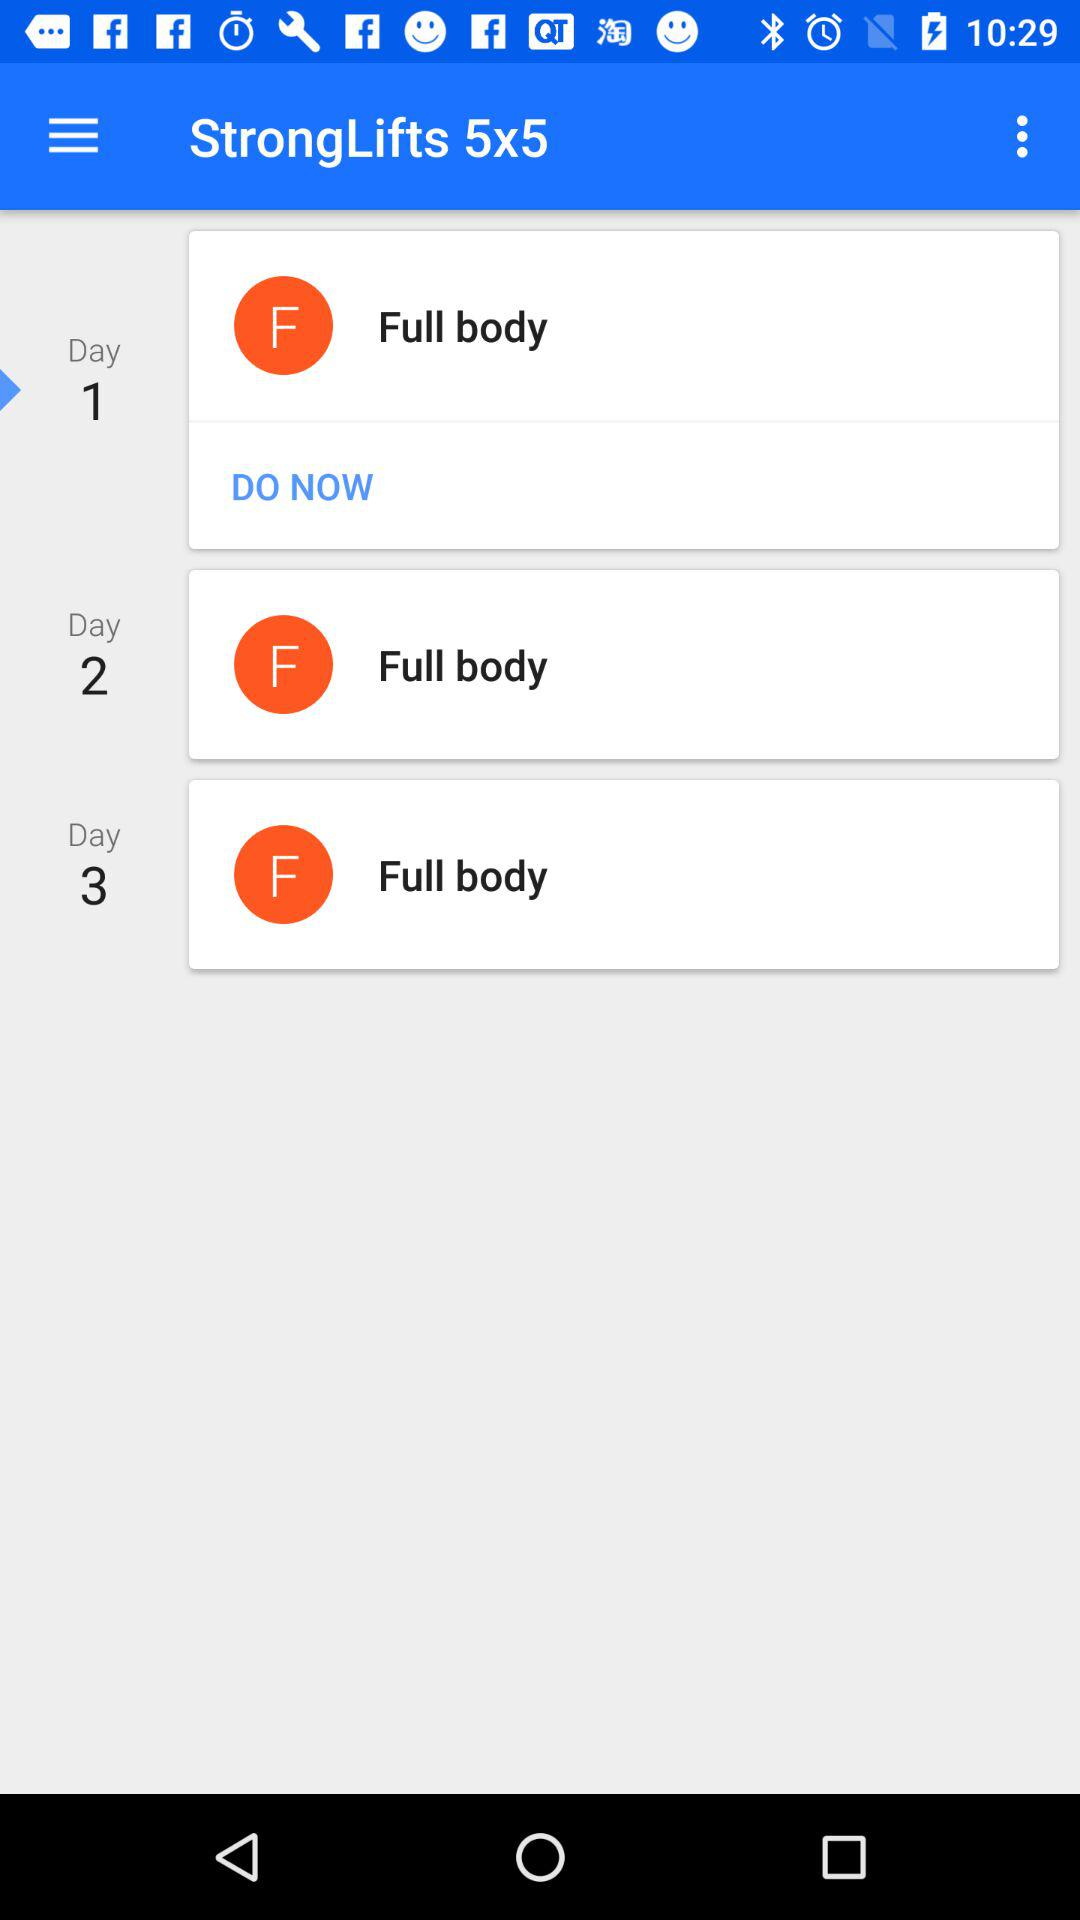How many days do I need to complete all three workouts?
Answer the question using a single word or phrase. 3 